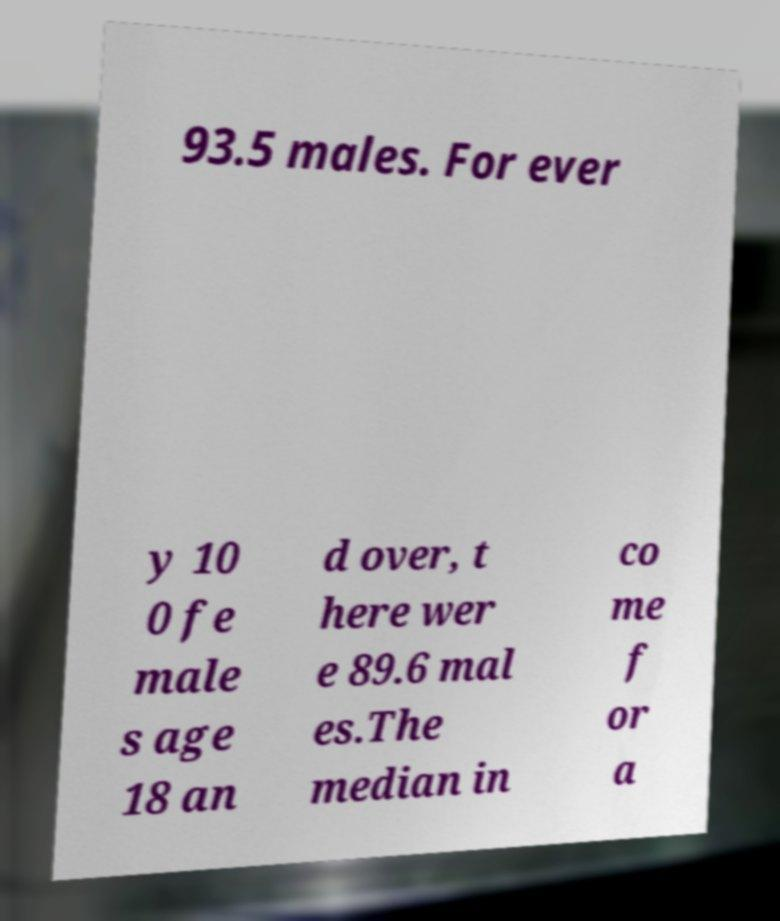Please read and relay the text visible in this image. What does it say? 93.5 males. For ever y 10 0 fe male s age 18 an d over, t here wer e 89.6 mal es.The median in co me f or a 